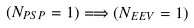Convert formula to latex. <formula><loc_0><loc_0><loc_500><loc_500>( N _ { P S P } = 1 ) \Longrightarrow ( N _ { E E V } = 1 )</formula> 